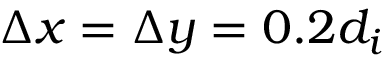<formula> <loc_0><loc_0><loc_500><loc_500>\Delta x = \Delta y = 0 . 2 d _ { i }</formula> 